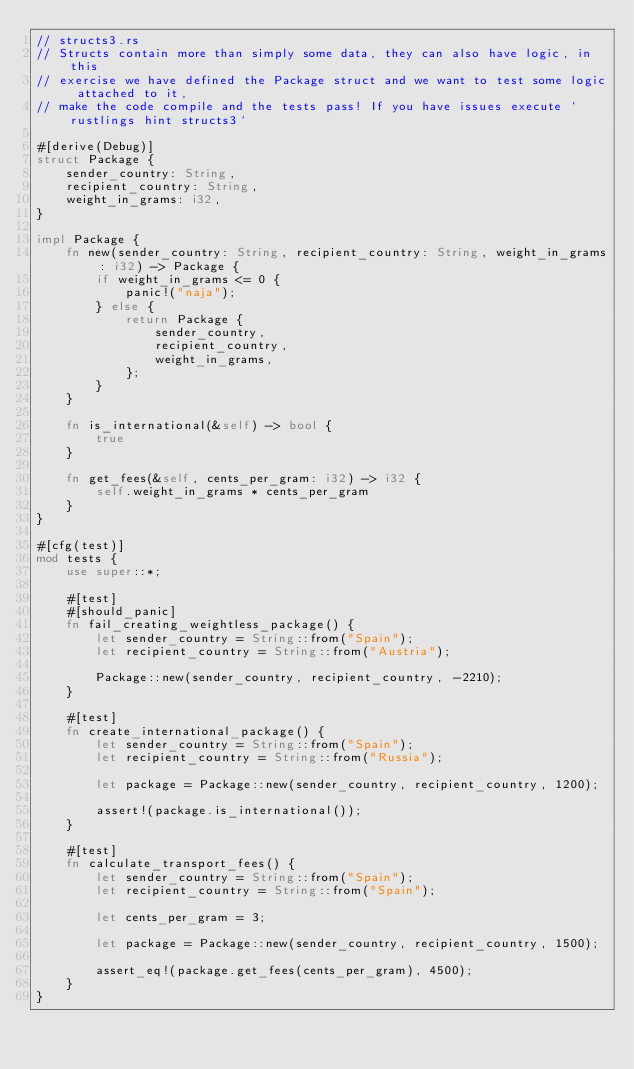<code> <loc_0><loc_0><loc_500><loc_500><_Rust_>// structs3.rs
// Structs contain more than simply some data, they can also have logic, in this
// exercise we have defined the Package struct and we want to test some logic attached to it,
// make the code compile and the tests pass! If you have issues execute `rustlings hint structs3`

#[derive(Debug)]
struct Package {
    sender_country: String,
    recipient_country: String,
    weight_in_grams: i32,
}

impl Package {
    fn new(sender_country: String, recipient_country: String, weight_in_grams: i32) -> Package {
        if weight_in_grams <= 0 {
            panic!("naja");
        } else {
            return Package {
                sender_country,
                recipient_country,
                weight_in_grams,
            };
        }
    }

    fn is_international(&self) -> bool {
        true
    }

    fn get_fees(&self, cents_per_gram: i32) -> i32 {
        self.weight_in_grams * cents_per_gram
    }
}

#[cfg(test)]
mod tests {
    use super::*;

    #[test]
    #[should_panic]
    fn fail_creating_weightless_package() {
        let sender_country = String::from("Spain");
        let recipient_country = String::from("Austria");

        Package::new(sender_country, recipient_country, -2210);
    }

    #[test]
    fn create_international_package() {
        let sender_country = String::from("Spain");
        let recipient_country = String::from("Russia");

        let package = Package::new(sender_country, recipient_country, 1200);

        assert!(package.is_international());
    }

    #[test]
    fn calculate_transport_fees() {
        let sender_country = String::from("Spain");
        let recipient_country = String::from("Spain");

        let cents_per_gram = 3;

        let package = Package::new(sender_country, recipient_country, 1500);

        assert_eq!(package.get_fees(cents_per_gram), 4500);
    }
}
</code> 